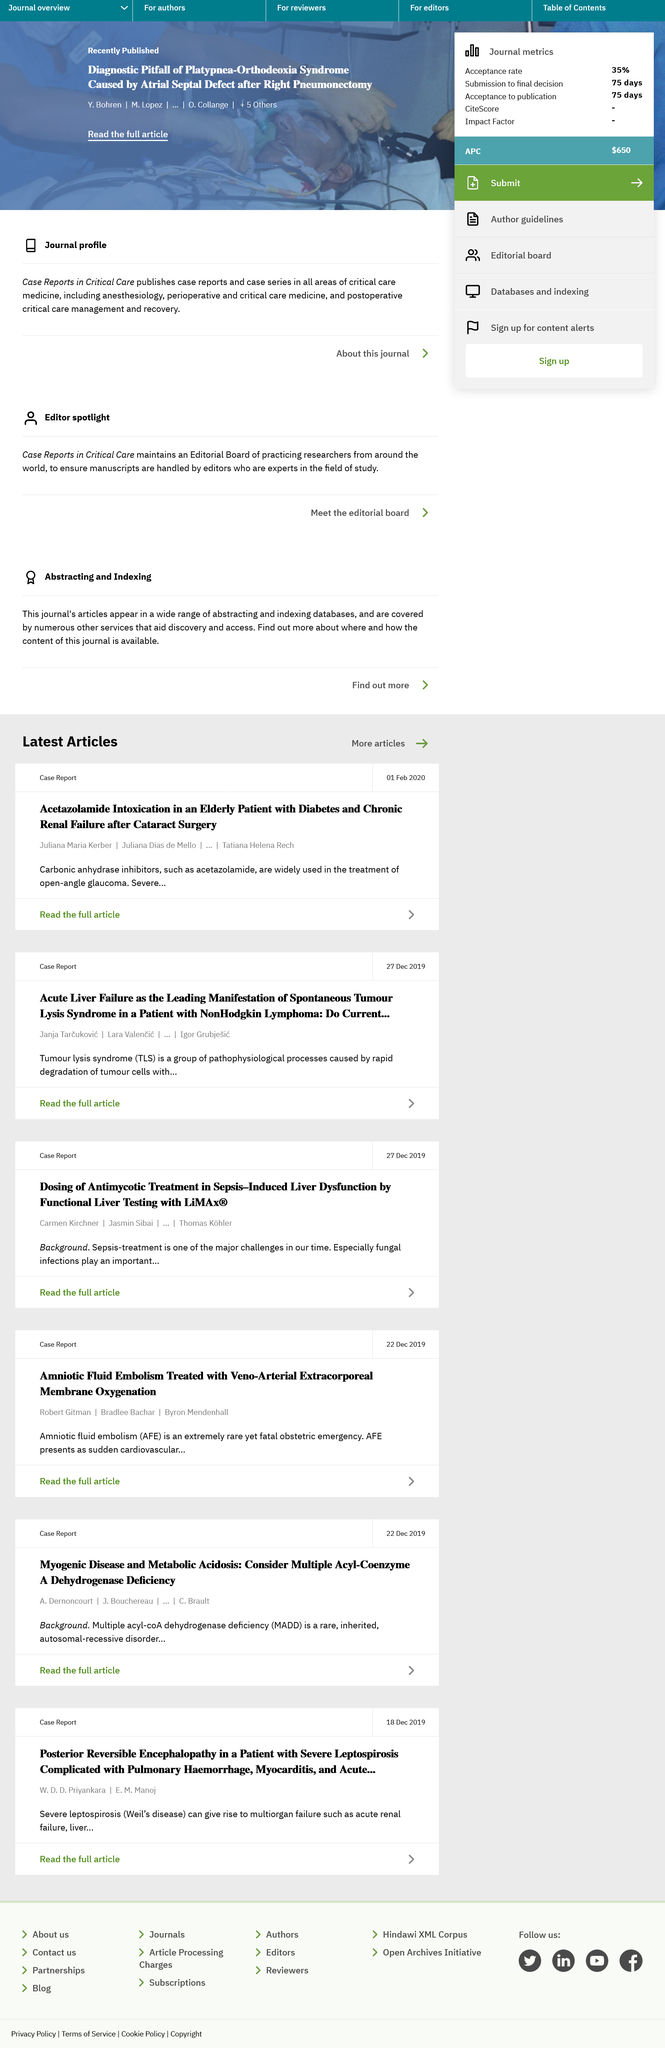List a handful of essential elements in this visual. Tumour lysis syndrome is a condition caused by the rapid breakdown of tumour cells, leading to an accumulation of intracellular components, such as potassium, phosphorus, and lactic acid, in the bloodstream. This can cause metabolic and electrolyte imbalances and potentially lead to serious complications, including kidney damage and cardiac arrhythmias. Carbonic anhydrase inhibitors are widely used in the open-angle treatment of glaucoma. 